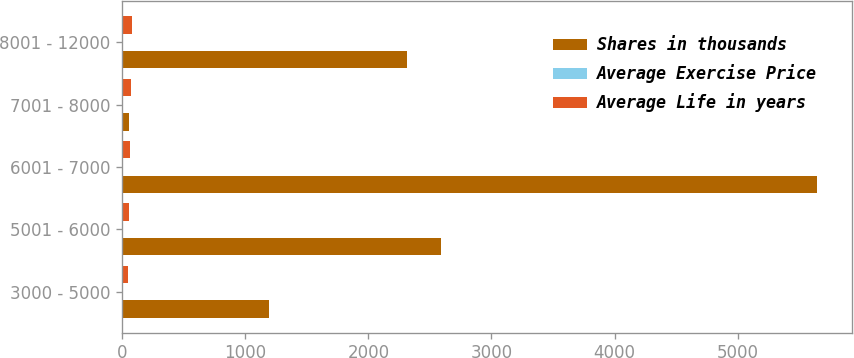Convert chart. <chart><loc_0><loc_0><loc_500><loc_500><stacked_bar_chart><ecel><fcel>3000 - 5000<fcel>5001 - 6000<fcel>6001 - 7000<fcel>7001 - 8000<fcel>8001 - 12000<nl><fcel>Shares in thousands<fcel>1190<fcel>2587<fcel>5642<fcel>59.07<fcel>2318<nl><fcel>Average Exercise Price<fcel>1.86<fcel>3.21<fcel>4.76<fcel>7.75<fcel>8.28<nl><fcel>Average Life in years<fcel>49.95<fcel>56.97<fcel>61.17<fcel>71.22<fcel>81.11<nl></chart> 